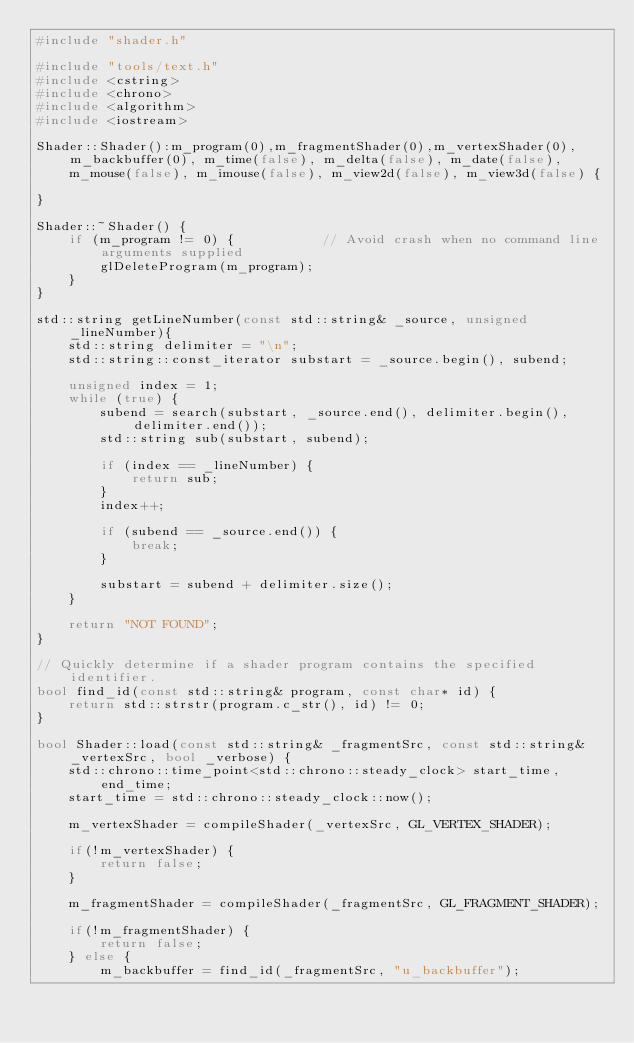Convert code to text. <code><loc_0><loc_0><loc_500><loc_500><_C++_>#include "shader.h"

#include "tools/text.h"
#include <cstring>
#include <chrono>
#include <algorithm>
#include <iostream>

Shader::Shader():m_program(0),m_fragmentShader(0),m_vertexShader(0), m_backbuffer(0), m_time(false), m_delta(false), m_date(false), m_mouse(false), m_imouse(false), m_view2d(false), m_view3d(false) {

}

Shader::~Shader() {
    if (m_program != 0) {           // Avoid crash when no command line arguments supplied
        glDeleteProgram(m_program);
    }
}

std::string getLineNumber(const std::string& _source, unsigned _lineNumber){
    std::string delimiter = "\n";
    std::string::const_iterator substart = _source.begin(), subend;

    unsigned index = 1;
    while (true) {
        subend = search(substart, _source.end(), delimiter.begin(), delimiter.end());
        std::string sub(substart, subend);

        if (index == _lineNumber) {
            return sub;
        }
        index++;

        if (subend == _source.end()) {
            break;
        }

        substart = subend + delimiter.size();
    }

    return "NOT FOUND";
}

// Quickly determine if a shader program contains the specified identifier.
bool find_id(const std::string& program, const char* id) {
    return std::strstr(program.c_str(), id) != 0;
}

bool Shader::load(const std::string& _fragmentSrc, const std::string& _vertexSrc, bool _verbose) {
    std::chrono::time_point<std::chrono::steady_clock> start_time, end_time;
    start_time = std::chrono::steady_clock::now();

    m_vertexShader = compileShader(_vertexSrc, GL_VERTEX_SHADER);

    if(!m_vertexShader) {
        return false;
    }

    m_fragmentShader = compileShader(_fragmentSrc, GL_FRAGMENT_SHADER);

    if(!m_fragmentShader) {
        return false;
    } else {
        m_backbuffer = find_id(_fragmentSrc, "u_backbuffer");</code> 